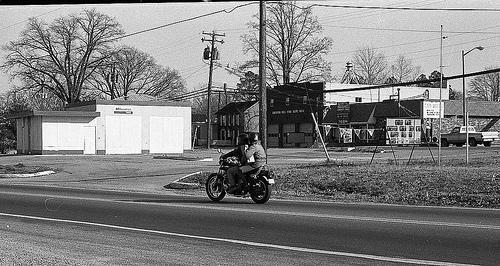How many people are on the bike?
Give a very brief answer. 2. How many trucks are in the photo?
Give a very brief answer. 1. 